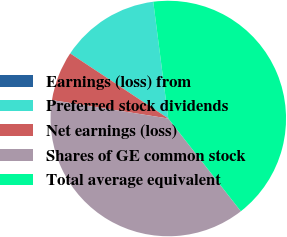Convert chart. <chart><loc_0><loc_0><loc_500><loc_500><pie_chart><fcel>Earnings (loss) from<fcel>Preferred stock dividends<fcel>Net earnings (loss)<fcel>Shares of GE common stock<fcel>Total average equivalent<nl><fcel>0.0%<fcel>13.64%<fcel>6.82%<fcel>38.06%<fcel>41.47%<nl></chart> 